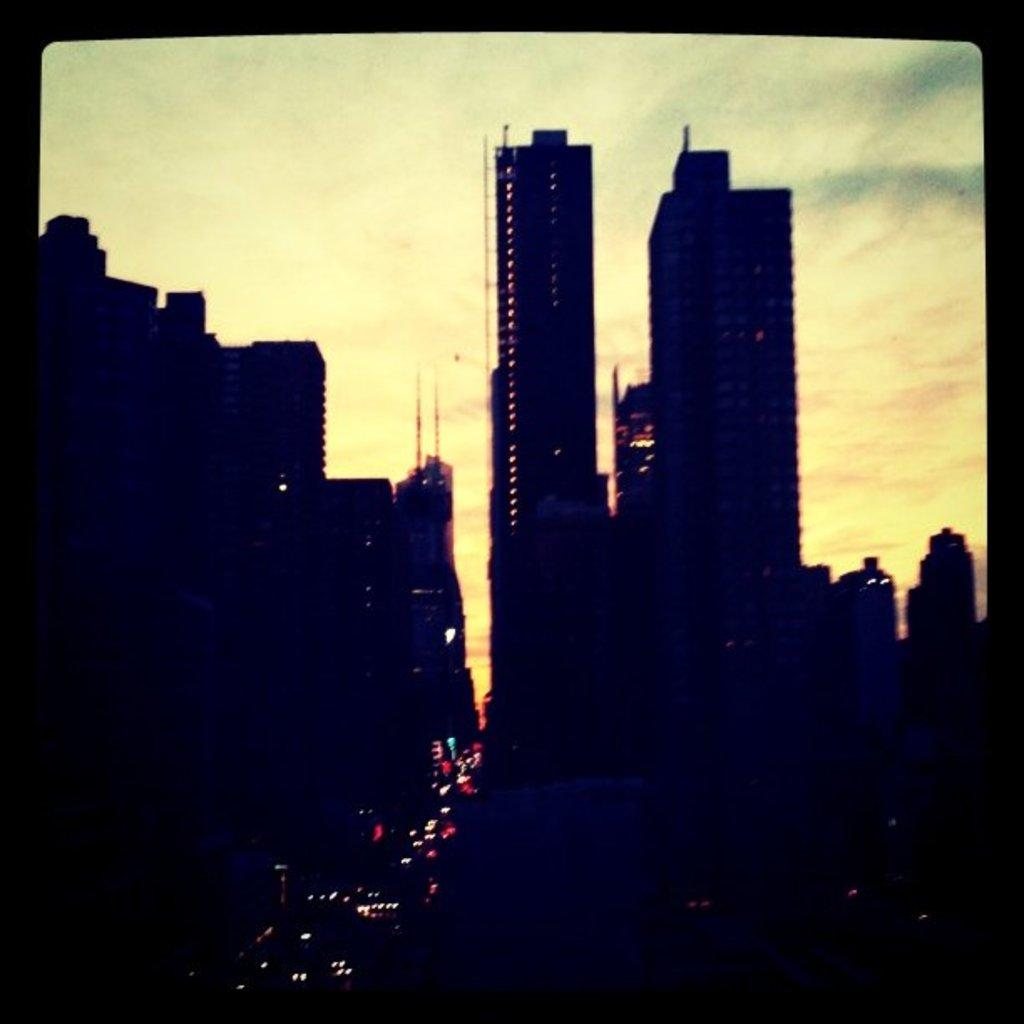What type of structures are present in the image? There are many buildings in the image. What can be seen illuminating the scene in the image? There are lights visible in the image. What is visible in the background of the image? The sky with clouds is visible in the background of the image. How would you describe the overall lighting in the image? The image appears to be dark. Where are the ants gathering for their meeting in the image? There are no ants or meetings present in the image. 